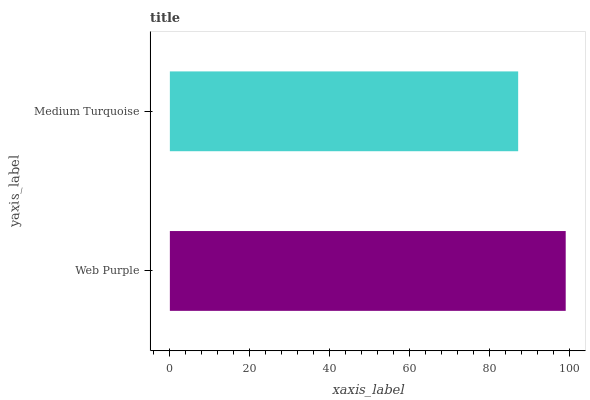Is Medium Turquoise the minimum?
Answer yes or no. Yes. Is Web Purple the maximum?
Answer yes or no. Yes. Is Medium Turquoise the maximum?
Answer yes or no. No. Is Web Purple greater than Medium Turquoise?
Answer yes or no. Yes. Is Medium Turquoise less than Web Purple?
Answer yes or no. Yes. Is Medium Turquoise greater than Web Purple?
Answer yes or no. No. Is Web Purple less than Medium Turquoise?
Answer yes or no. No. Is Web Purple the high median?
Answer yes or no. Yes. Is Medium Turquoise the low median?
Answer yes or no. Yes. Is Medium Turquoise the high median?
Answer yes or no. No. Is Web Purple the low median?
Answer yes or no. No. 